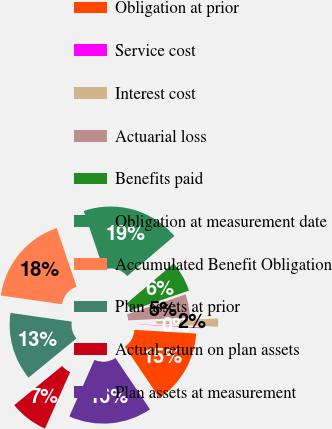Convert chart to OTSL. <chart><loc_0><loc_0><loc_500><loc_500><pie_chart><fcel>Obligation at prior<fcel>Service cost<fcel>Interest cost<fcel>Actuarial loss<fcel>Benefits paid<fcel>Obligation at measurement date<fcel>Accumulated Benefit Obligation<fcel>Plan assets at prior<fcel>Actual return on plan assets<fcel>Plan assets at measurement<nl><fcel>14.62%<fcel>0.12%<fcel>1.58%<fcel>4.5%<fcel>5.96%<fcel>19.0%<fcel>17.54%<fcel>13.16%<fcel>7.43%<fcel>16.08%<nl></chart> 